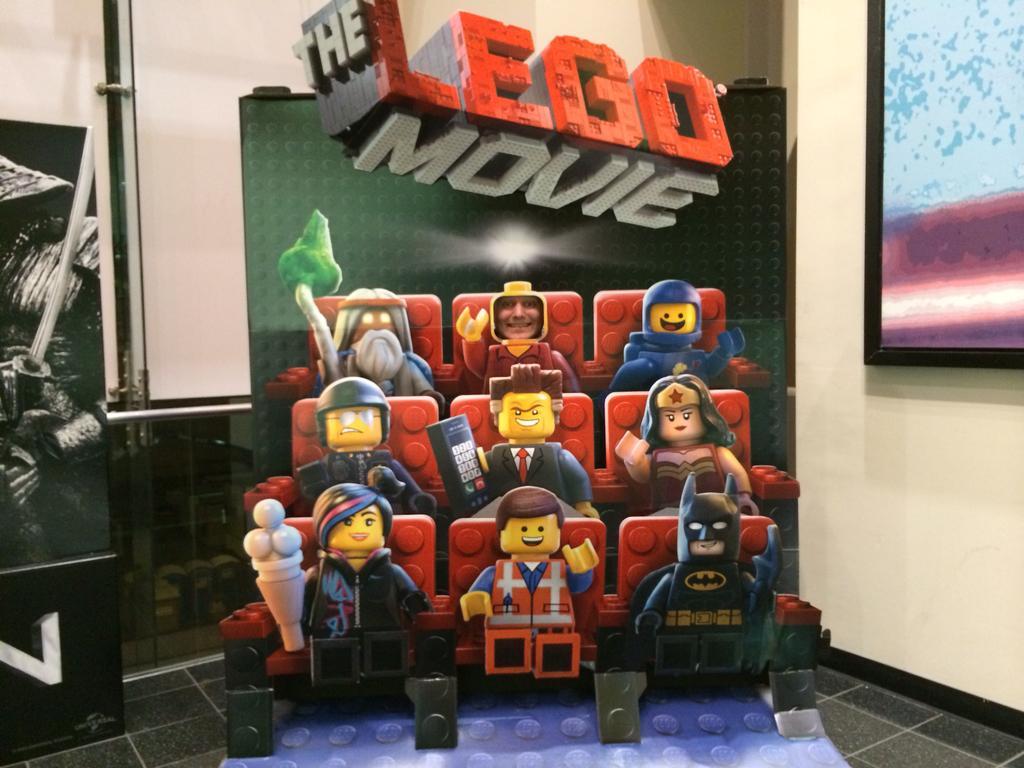In one or two sentences, can you explain what this image depicts? In the center of the image there is a board and we can see toys. On the right there is a screen placed on the wall. In the background there is a wall. On the left we can see a board. 